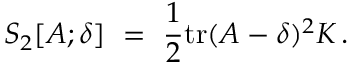<formula> <loc_0><loc_0><loc_500><loc_500>S _ { 2 } [ A ; \delta ] = \frac { 1 } { 2 } t r ( A - \delta ) ^ { 2 } K \, .</formula> 